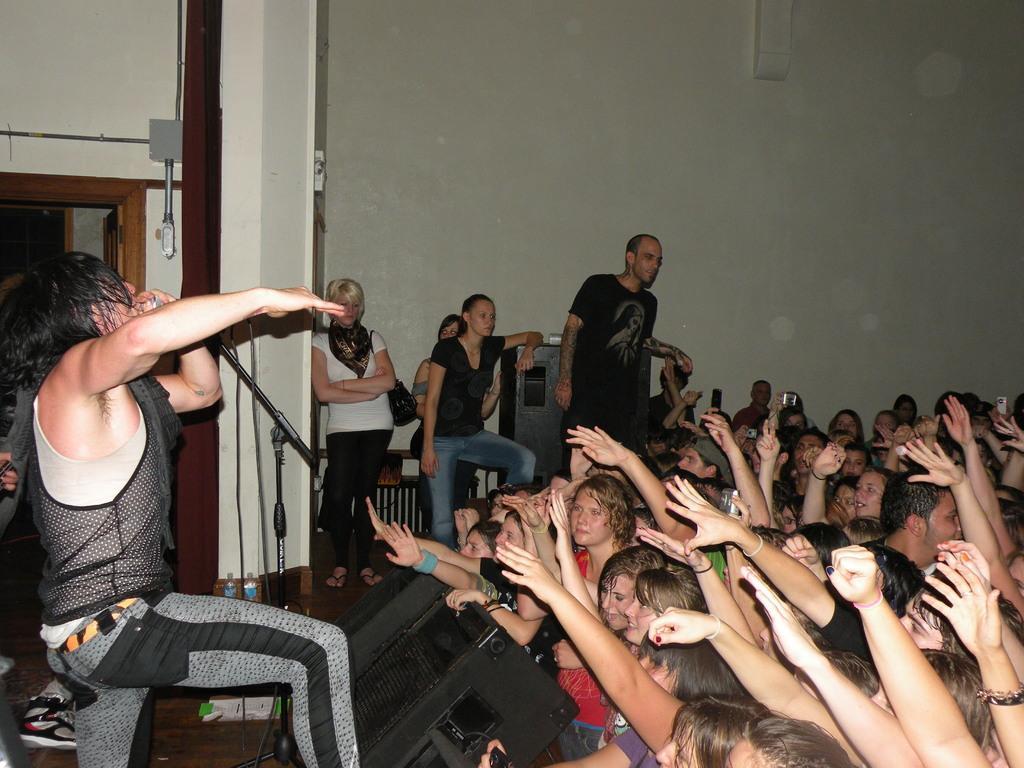Please provide a concise description of this image. In this image I can see a man standing and holding a microphone stand, in-front of him there are so many other people standing. 